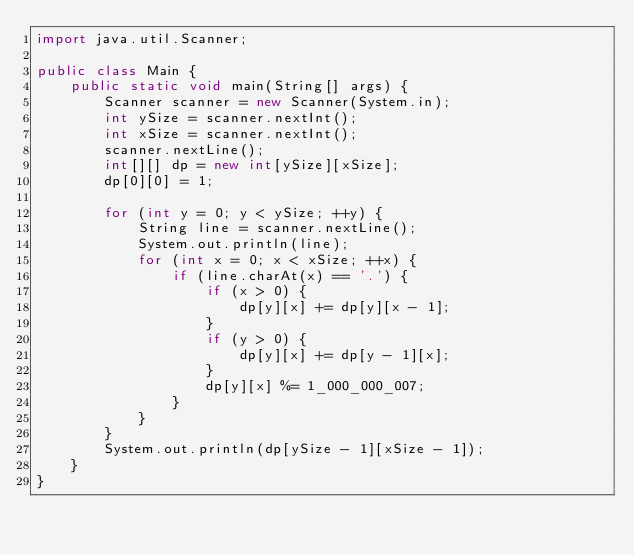Convert code to text. <code><loc_0><loc_0><loc_500><loc_500><_Java_>import java.util.Scanner;

public class Main {
    public static void main(String[] args) {
        Scanner scanner = new Scanner(System.in);
        int ySize = scanner.nextInt();
        int xSize = scanner.nextInt();
        scanner.nextLine();
        int[][] dp = new int[ySize][xSize];
        dp[0][0] = 1;

        for (int y = 0; y < ySize; ++y) {
            String line = scanner.nextLine();
            System.out.println(line);
            for (int x = 0; x < xSize; ++x) {
                if (line.charAt(x) == '.') {
                    if (x > 0) {
                        dp[y][x] += dp[y][x - 1];
                    }
                    if (y > 0) {
                        dp[y][x] += dp[y - 1][x];
                    }
                    dp[y][x] %= 1_000_000_007;
                }
            }
        }
        System.out.println(dp[ySize - 1][xSize - 1]);
    }
}
</code> 